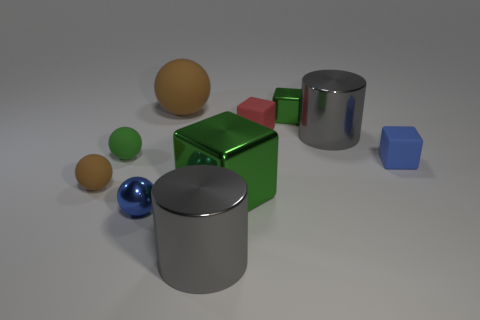What is the shape of the tiny green object that is the same material as the small blue cube?
Offer a terse response. Sphere. How many other things are the same shape as the small brown object?
Offer a terse response. 3. Is the size of the green metal thing behind the green sphere the same as the tiny blue shiny object?
Offer a terse response. Yes. Is the number of tiny matte objects behind the red matte thing greater than the number of big brown cubes?
Offer a very short reply. No. There is a gray shiny object that is behind the big cube; what number of gray metal cylinders are in front of it?
Provide a succinct answer. 1. Is the number of tiny shiny things on the left side of the small red rubber block less than the number of brown rubber objects?
Keep it short and to the point. Yes. There is a big metal cube behind the shiny cylinder that is on the left side of the red object; are there any things to the right of it?
Make the answer very short. Yes. Do the tiny brown ball and the blue block that is behind the blue metallic sphere have the same material?
Your answer should be compact. Yes. What is the color of the small metal thing that is in front of the gray cylinder behind the blue metallic thing?
Keep it short and to the point. Blue. Is there another cube of the same color as the large metal cube?
Provide a short and direct response. Yes. 